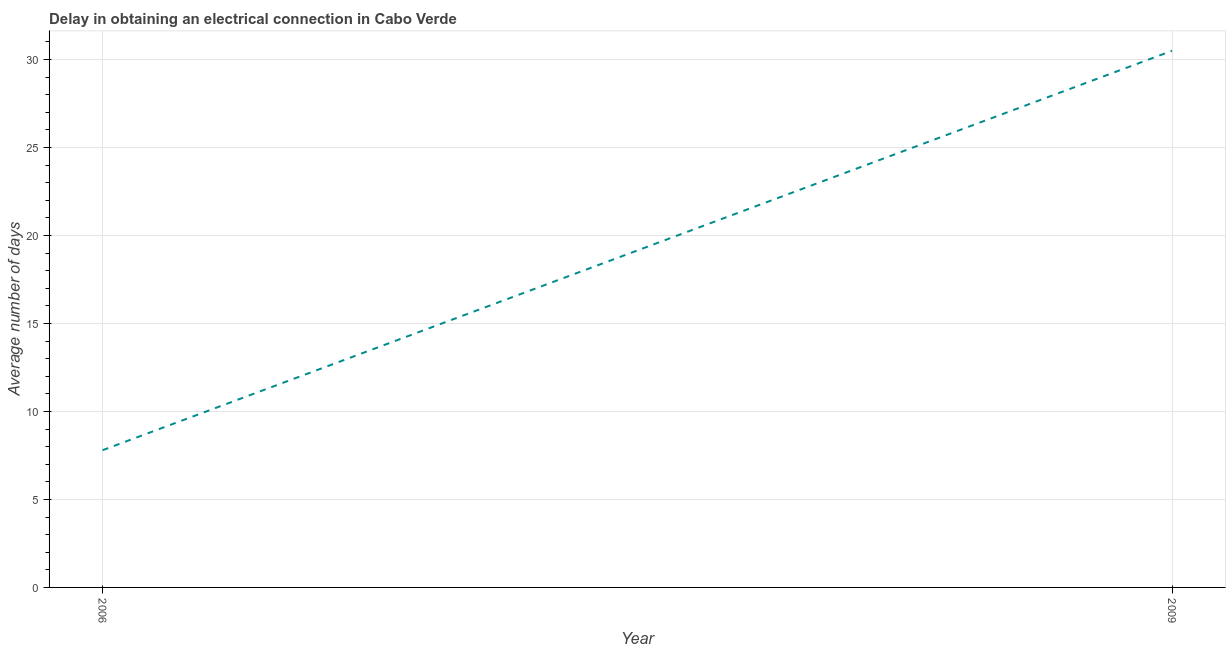Across all years, what is the maximum dalay in electrical connection?
Provide a short and direct response. 30.5. In which year was the dalay in electrical connection minimum?
Offer a terse response. 2006. What is the sum of the dalay in electrical connection?
Provide a succinct answer. 38.3. What is the difference between the dalay in electrical connection in 2006 and 2009?
Provide a succinct answer. -22.7. What is the average dalay in electrical connection per year?
Provide a short and direct response. 19.15. What is the median dalay in electrical connection?
Your answer should be compact. 19.15. What is the ratio of the dalay in electrical connection in 2006 to that in 2009?
Your response must be concise. 0.26. Is the dalay in electrical connection in 2006 less than that in 2009?
Make the answer very short. Yes. How many lines are there?
Ensure brevity in your answer.  1. How many years are there in the graph?
Give a very brief answer. 2. What is the difference between two consecutive major ticks on the Y-axis?
Offer a terse response. 5. Does the graph contain grids?
Your response must be concise. Yes. What is the title of the graph?
Keep it short and to the point. Delay in obtaining an electrical connection in Cabo Verde. What is the label or title of the X-axis?
Provide a short and direct response. Year. What is the label or title of the Y-axis?
Provide a succinct answer. Average number of days. What is the Average number of days in 2006?
Your answer should be compact. 7.8. What is the Average number of days in 2009?
Offer a terse response. 30.5. What is the difference between the Average number of days in 2006 and 2009?
Offer a terse response. -22.7. What is the ratio of the Average number of days in 2006 to that in 2009?
Provide a short and direct response. 0.26. 